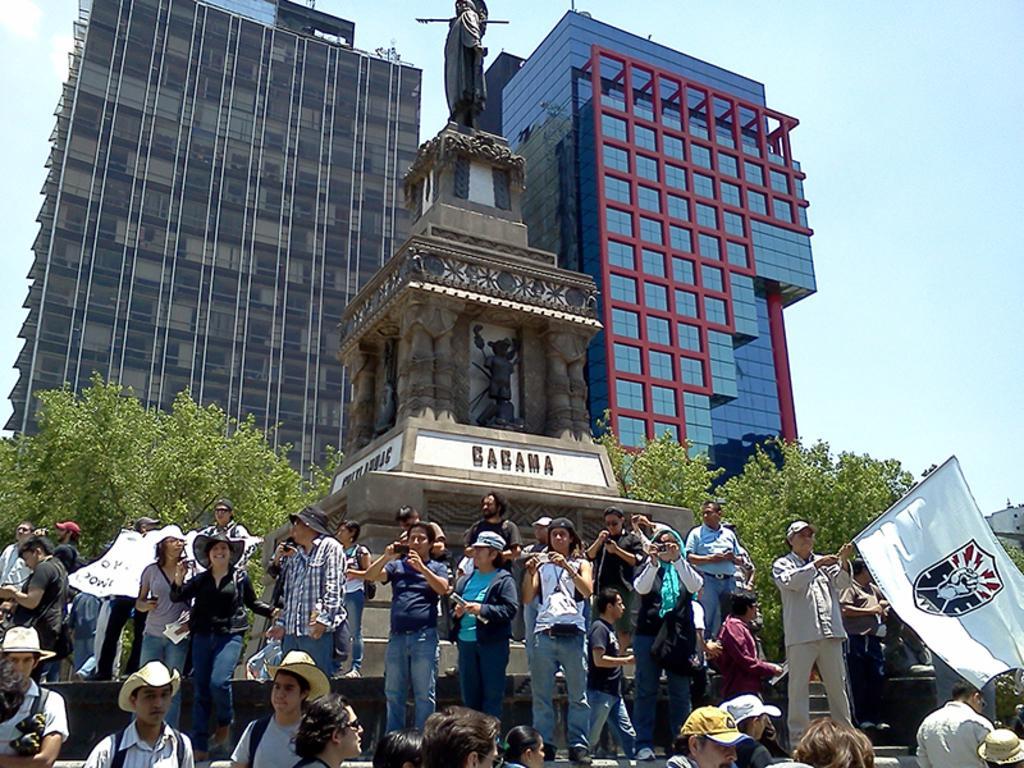How would you summarize this image in a sentence or two? In this picture, we can see a few people holding some objects, like flags, poles, statue and some text on it, we can see buildings, trees, and the sky. 